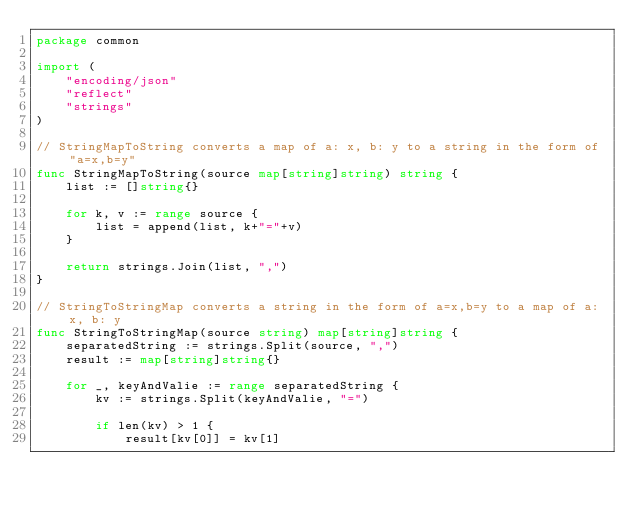<code> <loc_0><loc_0><loc_500><loc_500><_Go_>package common

import (
	"encoding/json"
	"reflect"
	"strings"
)

// StringMapToString converts a map of a: x, b: y to a string in the form of "a=x,b=y"
func StringMapToString(source map[string]string) string {
	list := []string{}

	for k, v := range source {
		list = append(list, k+"="+v)
	}

	return strings.Join(list, ",")
}

// StringToStringMap converts a string in the form of a=x,b=y to a map of a: x, b: y
func StringToStringMap(source string) map[string]string {
	separatedString := strings.Split(source, ",")
	result := map[string]string{}

	for _, keyAndValie := range separatedString {
		kv := strings.Split(keyAndValie, "=")

		if len(kv) > 1 {
			result[kv[0]] = kv[1]</code> 